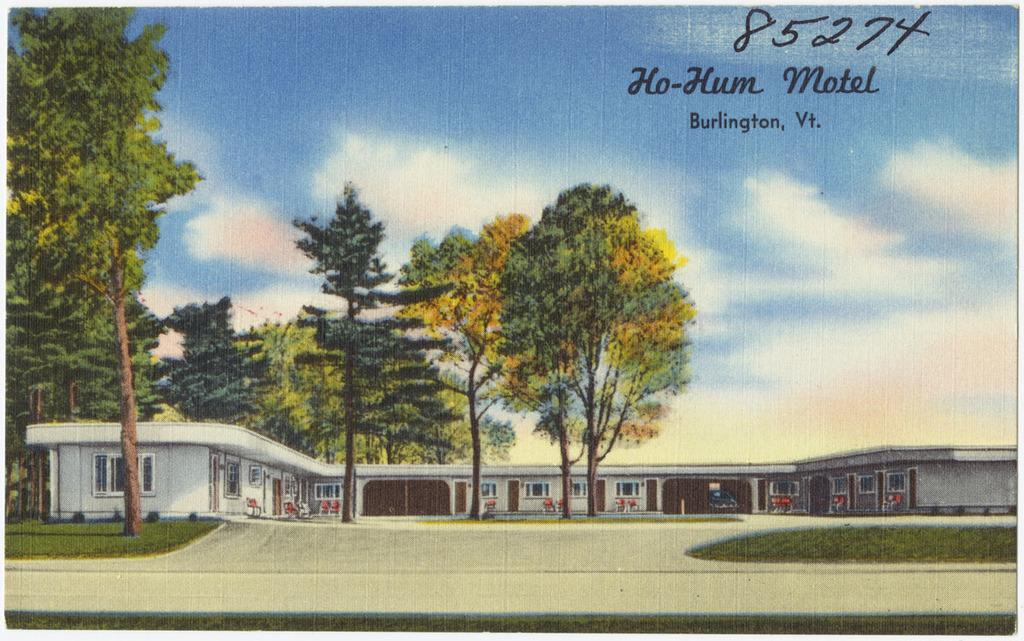<image>
Provide a brief description of the given image. Postcard with the numbers 85274 on top and a picture of trees as well as a building. 